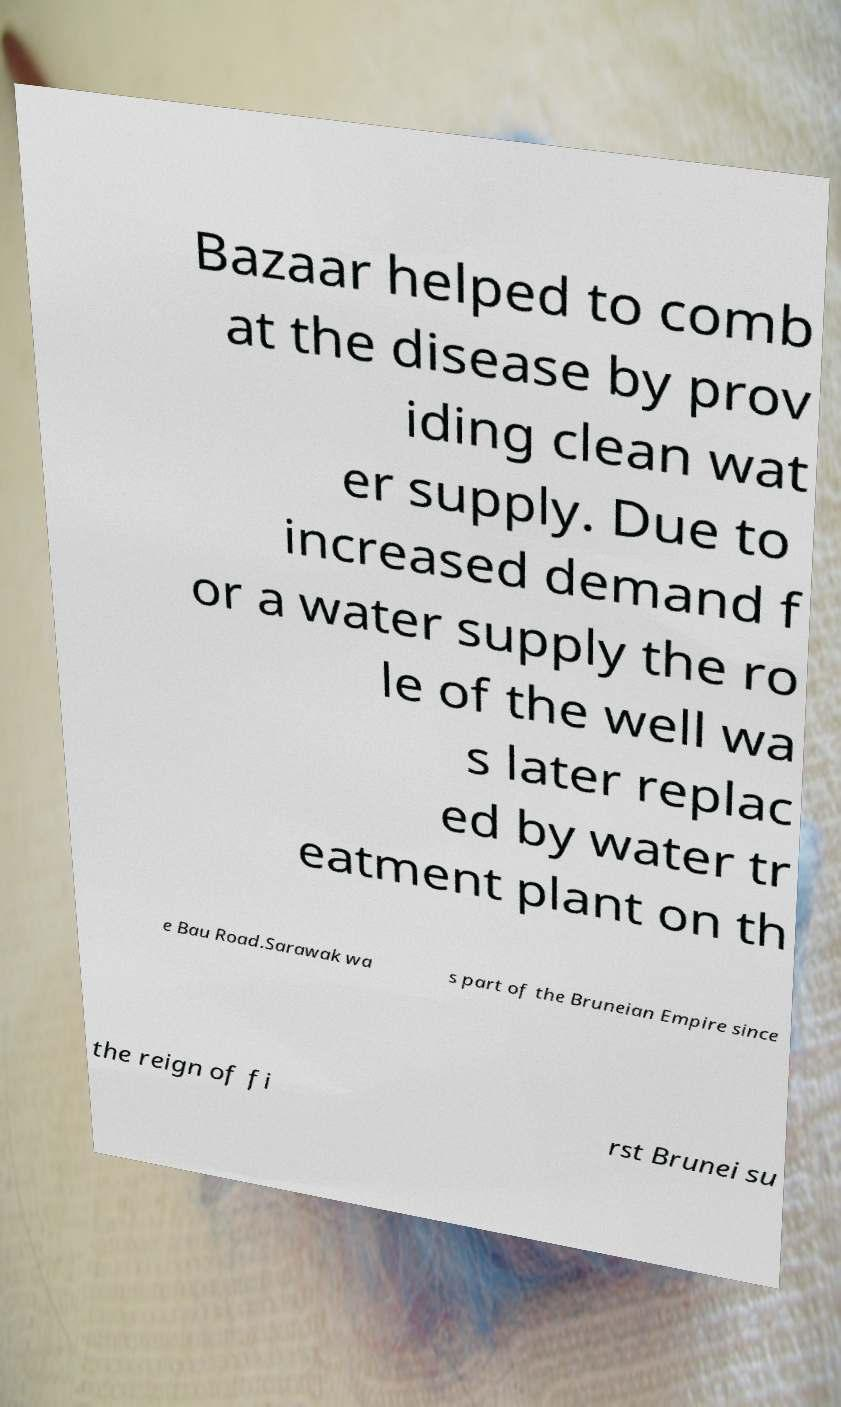Please read and relay the text visible in this image. What does it say? Bazaar helped to comb at the disease by prov iding clean wat er supply. Due to increased demand f or a water supply the ro le of the well wa s later replac ed by water tr eatment plant on th e Bau Road.Sarawak wa s part of the Bruneian Empire since the reign of fi rst Brunei su 